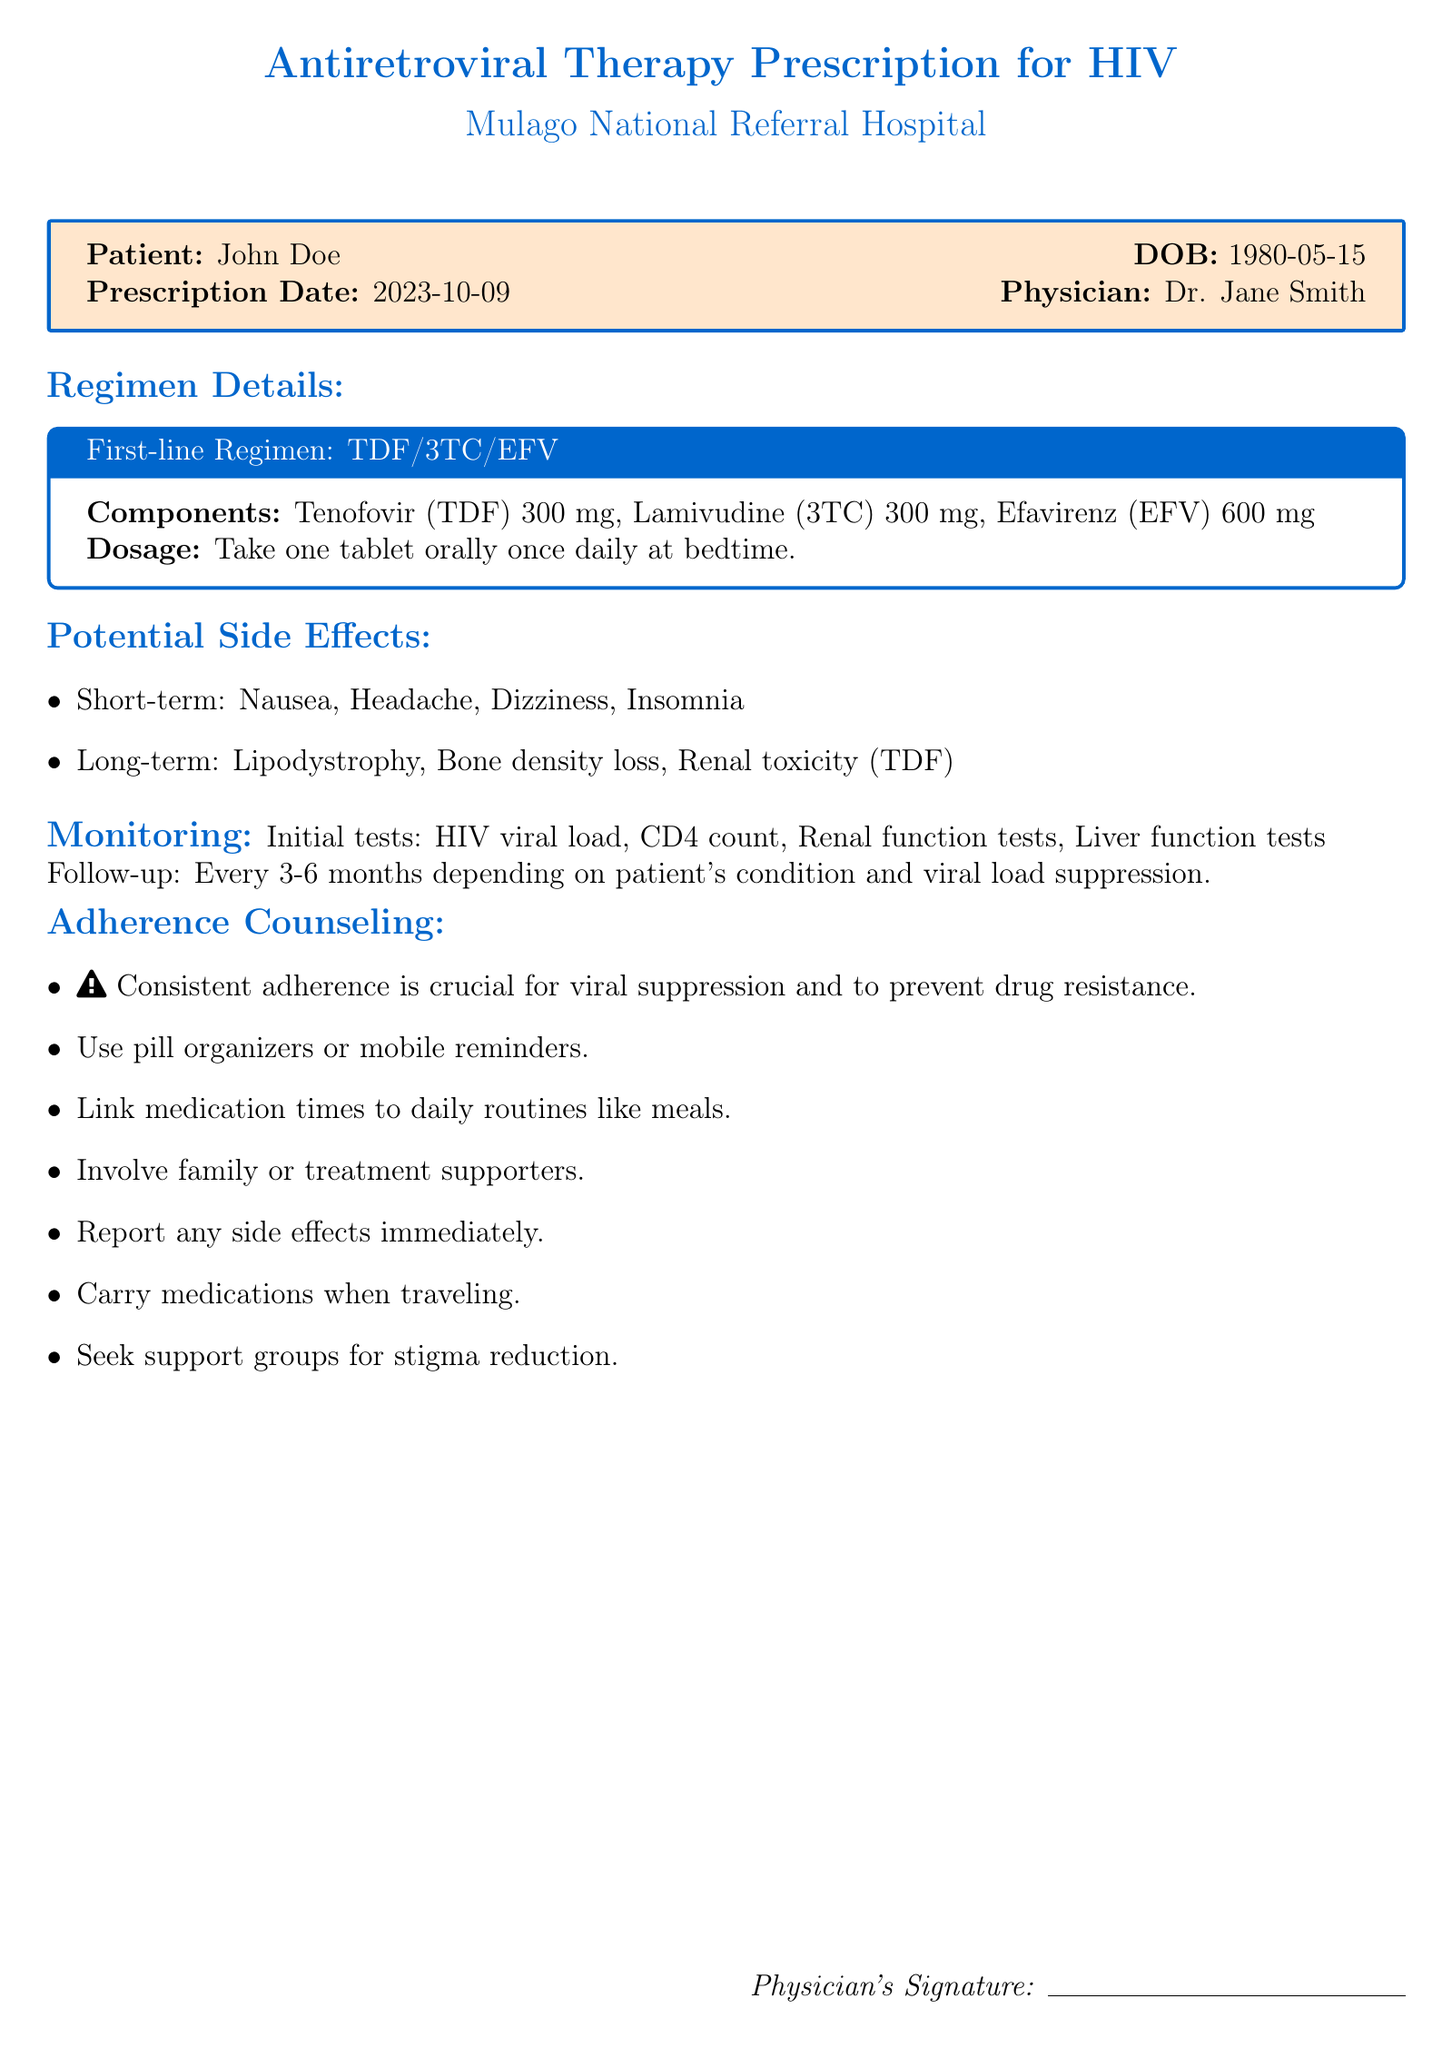What is the patient's name? The patient's name is stated at the beginning of the prescription document.
Answer: John Doe What is the prescription date? The prescription date is provided near the patient's details in the document.
Answer: 2023-10-09 What is the first-line regimen prescribed? The document specifies the first-line regimen under the regimen details section.
Answer: TDF/3TC/EFV What is the dosage for the medication? The dosage is mentioned in the first-line regimen box within the document.
Answer: One tablet orally once daily at bedtime Which potential short-term side effect is listed? The document lists side effects in two categories, allowing identification of short-term effects.
Answer: Nausea How often should follow-up monitoring occur? This information is mentioned in the monitoring section of the document.
Answer: Every 3-6 months What is one adherence counseling strategy mentioned? The adherence counseling section contains several strategies for better medication adherence.
Answer: Use pill organizers or mobile reminders What tests should be done initially for monitoring? The document lists initial tests required for monitoring in the patient's treatment.
Answer: HIV viral load, CD4 count, Renal function tests, Liver function tests What should a patient report immediately? The adherence counseling section advises on important actions to take regarding medication side effects.
Answer: Any side effects 